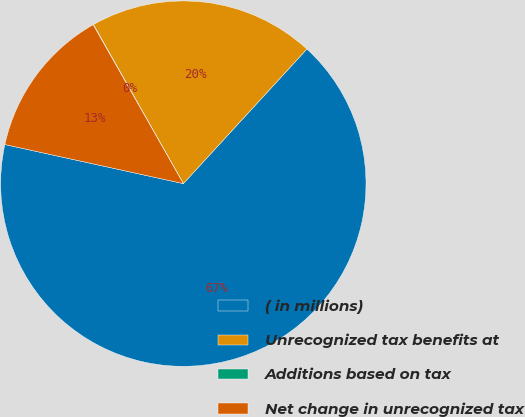<chart> <loc_0><loc_0><loc_500><loc_500><pie_chart><fcel>( in millions)<fcel>Unrecognized tax benefits at<fcel>Additions based on tax<fcel>Net change in unrecognized tax<nl><fcel>66.61%<fcel>20.01%<fcel>0.03%<fcel>13.35%<nl></chart> 